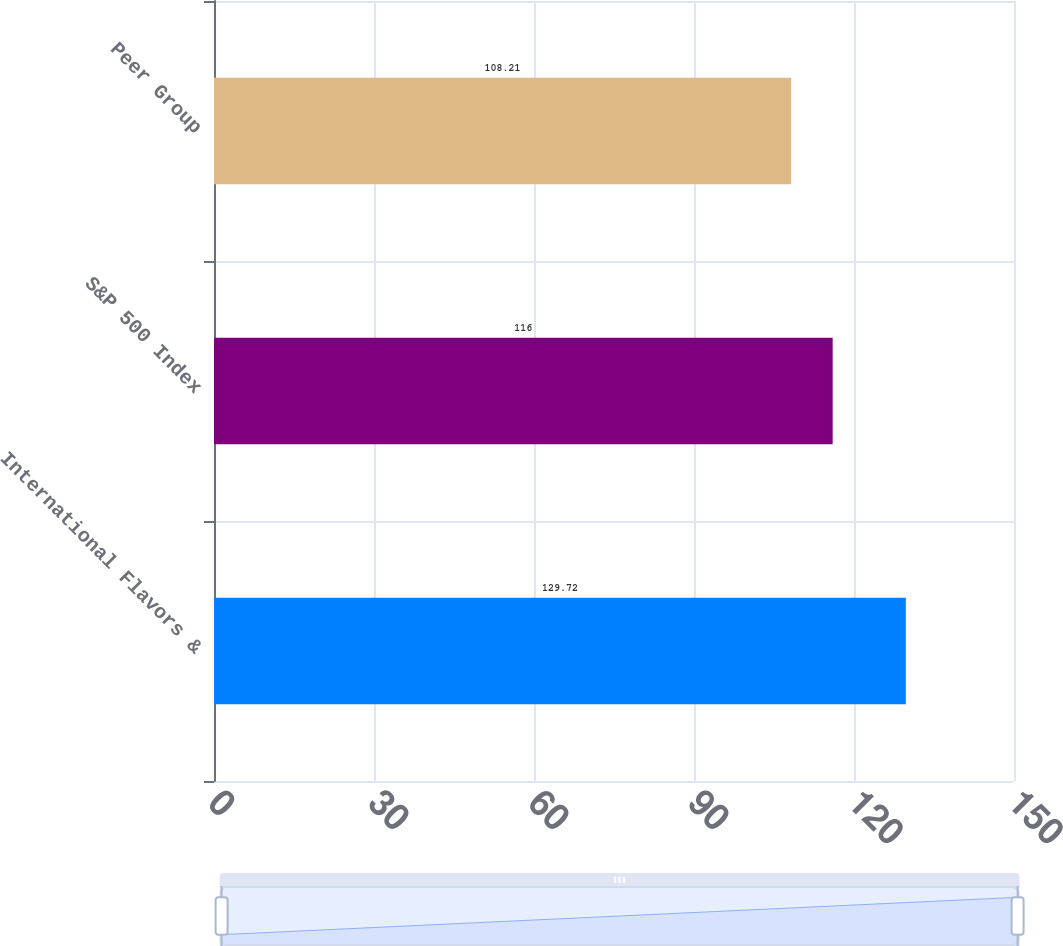Convert chart. <chart><loc_0><loc_0><loc_500><loc_500><bar_chart><fcel>International Flavors &<fcel>S&P 500 Index<fcel>Peer Group<nl><fcel>129.72<fcel>116<fcel>108.21<nl></chart> 